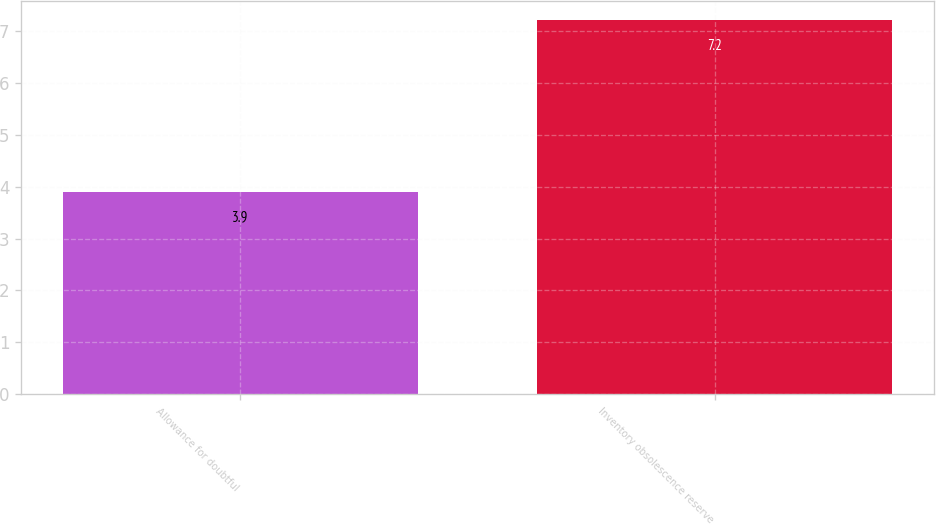<chart> <loc_0><loc_0><loc_500><loc_500><bar_chart><fcel>Allowance for doubtful<fcel>Inventory obsolescence reserve<nl><fcel>3.9<fcel>7.2<nl></chart> 